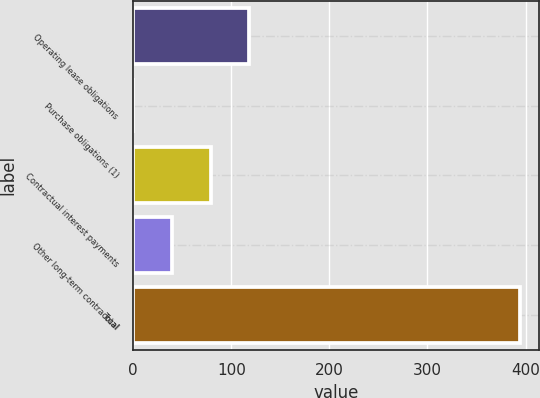Convert chart to OTSL. <chart><loc_0><loc_0><loc_500><loc_500><bar_chart><fcel>Operating lease obligations<fcel>Purchase obligations (1)<fcel>Contractual interest payments<fcel>Other long-term contractual<fcel>Total<nl><fcel>118.27<fcel>0.1<fcel>78.88<fcel>39.49<fcel>394<nl></chart> 